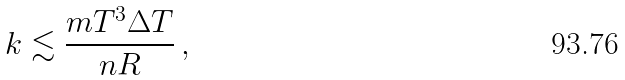Convert formula to latex. <formula><loc_0><loc_0><loc_500><loc_500>k \lesssim \frac { m T ^ { 3 } \Delta T } { n R } \, ,</formula> 